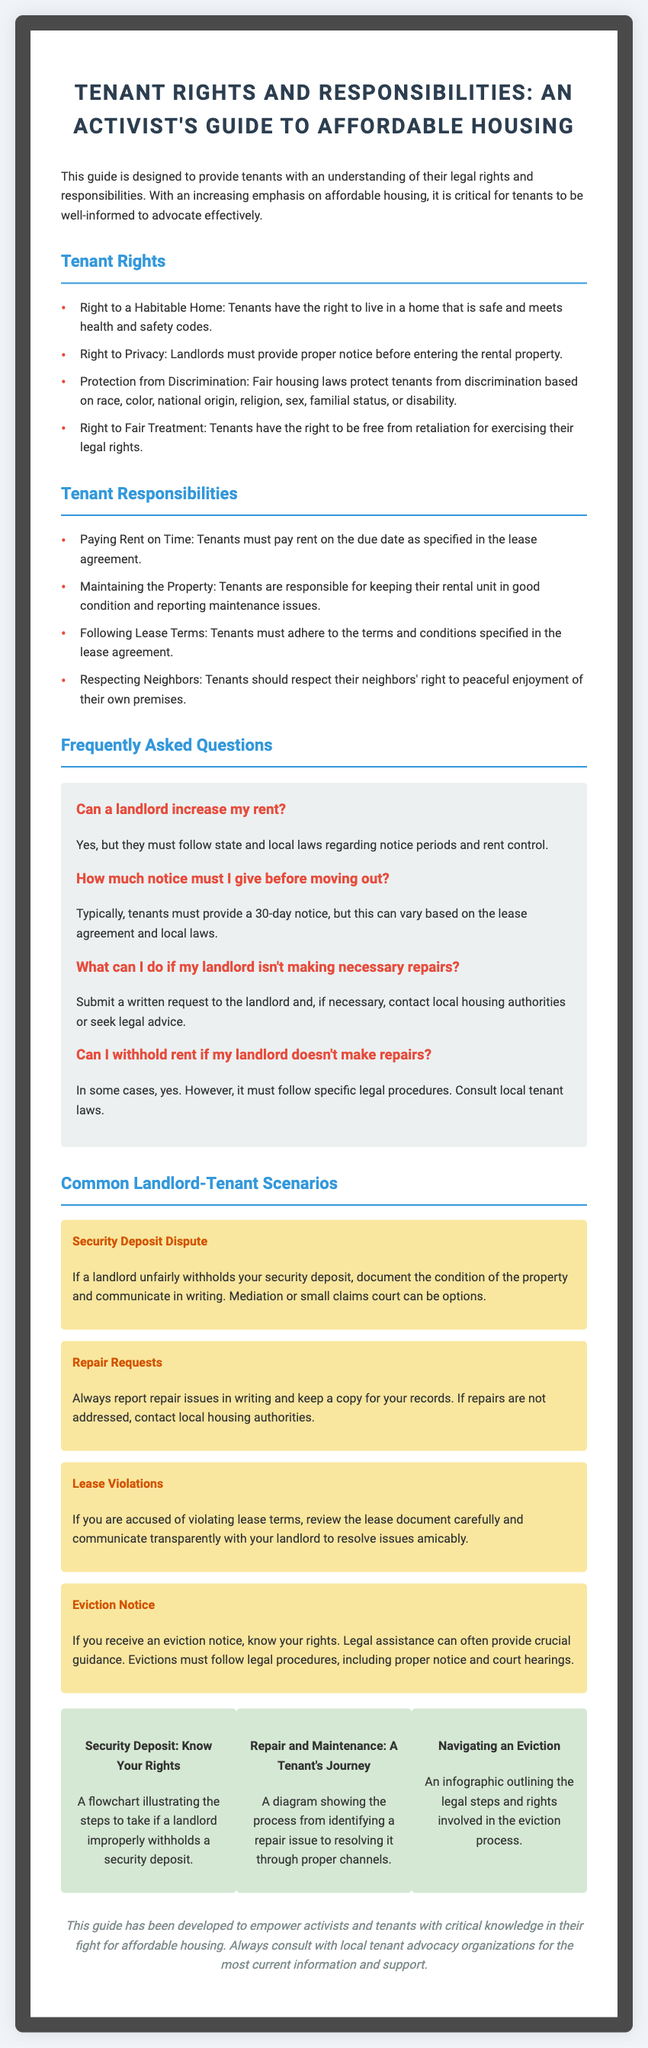What is the title of the document? The title of the document is found at the top and summarizes its purpose, specifically regarding tenant advocacy.
Answer: Tenant Rights and Responsibilities: An Activist's Guide to Affordable Housing What is one right of tenants outlined in the document? The document lists several rights of tenants, such as those related to living conditions and discrimination protection.
Answer: Right to a Habitable Home What is the standard notice period for moving out? The document specifies typical notice periods for tenants, which are influenced by the lease agreement and local laws.
Answer: 30-day notice What should a tenant do if their landlord does not make repairs? This question requires understanding of the advice given regarding landlord engagement when repairs are needed.
Answer: Submit a written request What is one common landlord-tenant scenario discussed? The document lists various scenarios to illustrate potential conflicts between landlords and tenants.
Answer: Security Deposit Dispute How many graphics are included in the document? The number of graphics is presented in a visually clear manner, summarizing specific situations in landlord-tenant relations.
Answer: 3 What is the main purpose of this guide? The document’s introduction clarifies its mission to inform and empower a specific audience.
Answer: To provide tenants with an understanding of their legal rights and responsibilities What should tenants do if they face an eviction notice? The document offers counsel specific to situations involving eviction, emphasizing understanding rights and legal guidance.
Answer: Know your rights What type of information does the "Frequently Asked Questions" section contain? This section offers answers to common concerns that tenants may have regarding their rights and landlord practices.
Answer: Tenant concerns and answers 